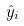Convert formula to latex. <formula><loc_0><loc_0><loc_500><loc_500>\hat { y } _ { i }</formula> 